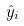Convert formula to latex. <formula><loc_0><loc_0><loc_500><loc_500>\hat { y } _ { i }</formula> 